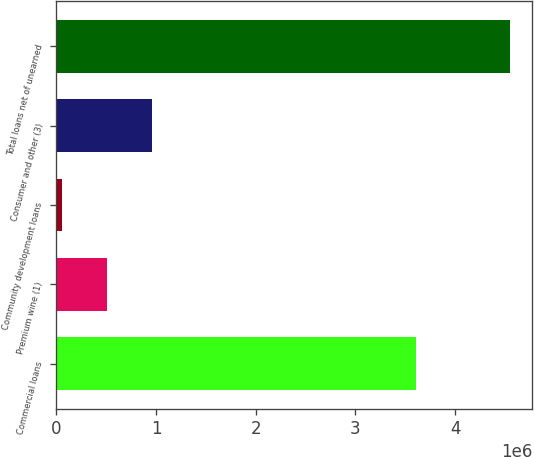Convert chart. <chart><loc_0><loc_0><loc_500><loc_500><bar_chart><fcel>Commercial loans<fcel>Premium wine (1)<fcel>Community development loans<fcel>Consumer and other (3)<fcel>Total loans net of unearned<nl><fcel>3.60364e+06<fcel>508743<fcel>59926<fcel>957560<fcel>4.54809e+06<nl></chart> 